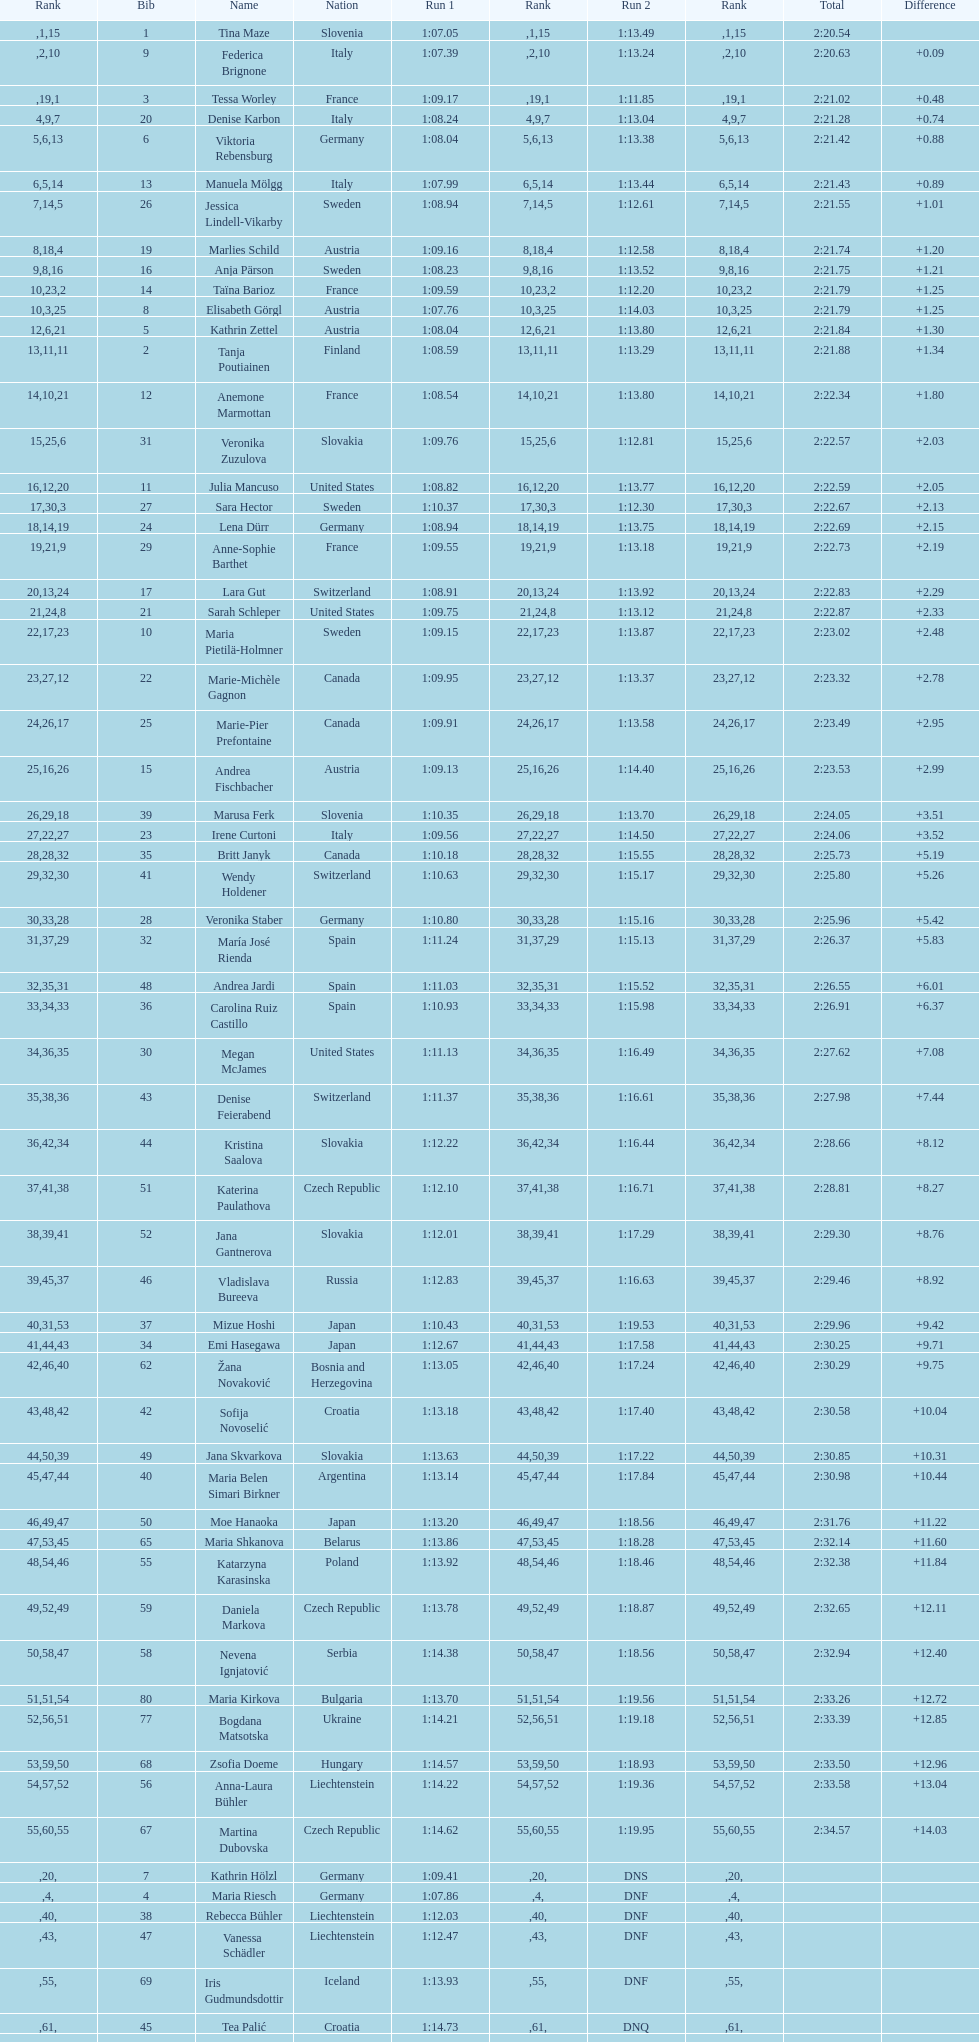Parse the full table. {'header': ['Rank', 'Bib', 'Name', 'Nation', 'Run 1', 'Rank', 'Run 2', 'Rank', 'Total', 'Difference'], 'rows': [['', '1', 'Tina Maze', 'Slovenia', '1:07.05', '1', '1:13.49', '15', '2:20.54', ''], ['', '9', 'Federica Brignone', 'Italy', '1:07.39', '2', '1:13.24', '10', '2:20.63', '+0.09'], ['', '3', 'Tessa Worley', 'France', '1:09.17', '19', '1:11.85', '1', '2:21.02', '+0.48'], ['4', '20', 'Denise Karbon', 'Italy', '1:08.24', '9', '1:13.04', '7', '2:21.28', '+0.74'], ['5', '6', 'Viktoria Rebensburg', 'Germany', '1:08.04', '6', '1:13.38', '13', '2:21.42', '+0.88'], ['6', '13', 'Manuela Mölgg', 'Italy', '1:07.99', '5', '1:13.44', '14', '2:21.43', '+0.89'], ['7', '26', 'Jessica Lindell-Vikarby', 'Sweden', '1:08.94', '14', '1:12.61', '5', '2:21.55', '+1.01'], ['8', '19', 'Marlies Schild', 'Austria', '1:09.16', '18', '1:12.58', '4', '2:21.74', '+1.20'], ['9', '16', 'Anja Pärson', 'Sweden', '1:08.23', '8', '1:13.52', '16', '2:21.75', '+1.21'], ['10', '14', 'Taïna Barioz', 'France', '1:09.59', '23', '1:12.20', '2', '2:21.79', '+1.25'], ['10', '8', 'Elisabeth Görgl', 'Austria', '1:07.76', '3', '1:14.03', '25', '2:21.79', '+1.25'], ['12', '5', 'Kathrin Zettel', 'Austria', '1:08.04', '6', '1:13.80', '21', '2:21.84', '+1.30'], ['13', '2', 'Tanja Poutiainen', 'Finland', '1:08.59', '11', '1:13.29', '11', '2:21.88', '+1.34'], ['14', '12', 'Anemone Marmottan', 'France', '1:08.54', '10', '1:13.80', '21', '2:22.34', '+1.80'], ['15', '31', 'Veronika Zuzulova', 'Slovakia', '1:09.76', '25', '1:12.81', '6', '2:22.57', '+2.03'], ['16', '11', 'Julia Mancuso', 'United States', '1:08.82', '12', '1:13.77', '20', '2:22.59', '+2.05'], ['17', '27', 'Sara Hector', 'Sweden', '1:10.37', '30', '1:12.30', '3', '2:22.67', '+2.13'], ['18', '24', 'Lena Dürr', 'Germany', '1:08.94', '14', '1:13.75', '19', '2:22.69', '+2.15'], ['19', '29', 'Anne-Sophie Barthet', 'France', '1:09.55', '21', '1:13.18', '9', '2:22.73', '+2.19'], ['20', '17', 'Lara Gut', 'Switzerland', '1:08.91', '13', '1:13.92', '24', '2:22.83', '+2.29'], ['21', '21', 'Sarah Schleper', 'United States', '1:09.75', '24', '1:13.12', '8', '2:22.87', '+2.33'], ['22', '10', 'Maria Pietilä-Holmner', 'Sweden', '1:09.15', '17', '1:13.87', '23', '2:23.02', '+2.48'], ['23', '22', 'Marie-Michèle Gagnon', 'Canada', '1:09.95', '27', '1:13.37', '12', '2:23.32', '+2.78'], ['24', '25', 'Marie-Pier Prefontaine', 'Canada', '1:09.91', '26', '1:13.58', '17', '2:23.49', '+2.95'], ['25', '15', 'Andrea Fischbacher', 'Austria', '1:09.13', '16', '1:14.40', '26', '2:23.53', '+2.99'], ['26', '39', 'Marusa Ferk', 'Slovenia', '1:10.35', '29', '1:13.70', '18', '2:24.05', '+3.51'], ['27', '23', 'Irene Curtoni', 'Italy', '1:09.56', '22', '1:14.50', '27', '2:24.06', '+3.52'], ['28', '35', 'Britt Janyk', 'Canada', '1:10.18', '28', '1:15.55', '32', '2:25.73', '+5.19'], ['29', '41', 'Wendy Holdener', 'Switzerland', '1:10.63', '32', '1:15.17', '30', '2:25.80', '+5.26'], ['30', '28', 'Veronika Staber', 'Germany', '1:10.80', '33', '1:15.16', '28', '2:25.96', '+5.42'], ['31', '32', 'María José Rienda', 'Spain', '1:11.24', '37', '1:15.13', '29', '2:26.37', '+5.83'], ['32', '48', 'Andrea Jardi', 'Spain', '1:11.03', '35', '1:15.52', '31', '2:26.55', '+6.01'], ['33', '36', 'Carolina Ruiz Castillo', 'Spain', '1:10.93', '34', '1:15.98', '33', '2:26.91', '+6.37'], ['34', '30', 'Megan McJames', 'United States', '1:11.13', '36', '1:16.49', '35', '2:27.62', '+7.08'], ['35', '43', 'Denise Feierabend', 'Switzerland', '1:11.37', '38', '1:16.61', '36', '2:27.98', '+7.44'], ['36', '44', 'Kristina Saalova', 'Slovakia', '1:12.22', '42', '1:16.44', '34', '2:28.66', '+8.12'], ['37', '51', 'Katerina Paulathova', 'Czech Republic', '1:12.10', '41', '1:16.71', '38', '2:28.81', '+8.27'], ['38', '52', 'Jana Gantnerova', 'Slovakia', '1:12.01', '39', '1:17.29', '41', '2:29.30', '+8.76'], ['39', '46', 'Vladislava Bureeva', 'Russia', '1:12.83', '45', '1:16.63', '37', '2:29.46', '+8.92'], ['40', '37', 'Mizue Hoshi', 'Japan', '1:10.43', '31', '1:19.53', '53', '2:29.96', '+9.42'], ['41', '34', 'Emi Hasegawa', 'Japan', '1:12.67', '44', '1:17.58', '43', '2:30.25', '+9.71'], ['42', '62', 'Žana Novaković', 'Bosnia and Herzegovina', '1:13.05', '46', '1:17.24', '40', '2:30.29', '+9.75'], ['43', '42', 'Sofija Novoselić', 'Croatia', '1:13.18', '48', '1:17.40', '42', '2:30.58', '+10.04'], ['44', '49', 'Jana Skvarkova', 'Slovakia', '1:13.63', '50', '1:17.22', '39', '2:30.85', '+10.31'], ['45', '40', 'Maria Belen Simari Birkner', 'Argentina', '1:13.14', '47', '1:17.84', '44', '2:30.98', '+10.44'], ['46', '50', 'Moe Hanaoka', 'Japan', '1:13.20', '49', '1:18.56', '47', '2:31.76', '+11.22'], ['47', '65', 'Maria Shkanova', 'Belarus', '1:13.86', '53', '1:18.28', '45', '2:32.14', '+11.60'], ['48', '55', 'Katarzyna Karasinska', 'Poland', '1:13.92', '54', '1:18.46', '46', '2:32.38', '+11.84'], ['49', '59', 'Daniela Markova', 'Czech Republic', '1:13.78', '52', '1:18.87', '49', '2:32.65', '+12.11'], ['50', '58', 'Nevena Ignjatović', 'Serbia', '1:14.38', '58', '1:18.56', '47', '2:32.94', '+12.40'], ['51', '80', 'Maria Kirkova', 'Bulgaria', '1:13.70', '51', '1:19.56', '54', '2:33.26', '+12.72'], ['52', '77', 'Bogdana Matsotska', 'Ukraine', '1:14.21', '56', '1:19.18', '51', '2:33.39', '+12.85'], ['53', '68', 'Zsofia Doeme', 'Hungary', '1:14.57', '59', '1:18.93', '50', '2:33.50', '+12.96'], ['54', '56', 'Anna-Laura Bühler', 'Liechtenstein', '1:14.22', '57', '1:19.36', '52', '2:33.58', '+13.04'], ['55', '67', 'Martina Dubovska', 'Czech Republic', '1:14.62', '60', '1:19.95', '55', '2:34.57', '+14.03'], ['', '7', 'Kathrin Hölzl', 'Germany', '1:09.41', '20', 'DNS', '', '', ''], ['', '4', 'Maria Riesch', 'Germany', '1:07.86', '4', 'DNF', '', '', ''], ['', '38', 'Rebecca Bühler', 'Liechtenstein', '1:12.03', '40', 'DNF', '', '', ''], ['', '47', 'Vanessa Schädler', 'Liechtenstein', '1:12.47', '43', 'DNF', '', '', ''], ['', '69', 'Iris Gudmundsdottir', 'Iceland', '1:13.93', '55', 'DNF', '', '', ''], ['', '45', 'Tea Palić', 'Croatia', '1:14.73', '61', 'DNQ', '', '', ''], ['', '74', 'Macarena Simari Birkner', 'Argentina', '1:15.18', '62', 'DNQ', '', '', ''], ['', '72', 'Lavinia Chrystal', 'Australia', '1:15.35', '63', 'DNQ', '', '', ''], ['', '81', 'Lelde Gasuna', 'Latvia', '1:15.37', '64', 'DNQ', '', '', ''], ['', '64', 'Aleksandra Klus', 'Poland', '1:15.41', '65', 'DNQ', '', '', ''], ['', '78', 'Nino Tsiklauri', 'Georgia', '1:15.54', '66', 'DNQ', '', '', ''], ['', '66', 'Sarah Jarvis', 'New Zealand', '1:15.94', '67', 'DNQ', '', '', ''], ['', '61', 'Anna Berecz', 'Hungary', '1:15.95', '68', 'DNQ', '', '', ''], ['', '83', 'Sandra-Elena Narea', 'Romania', '1:16.67', '69', 'DNQ', '', '', ''], ['', '85', 'Iulia Petruta Craciun', 'Romania', '1:16.80', '70', 'DNQ', '', '', ''], ['', '82', 'Isabel van Buynder', 'Belgium', '1:17.06', '71', 'DNQ', '', '', ''], ['', '97', 'Liene Fimbauere', 'Latvia', '1:17.83', '72', 'DNQ', '', '', ''], ['', '86', 'Kristina Krone', 'Puerto Rico', '1:17.93', '73', 'DNQ', '', '', ''], ['', '88', 'Nicole Valcareggi', 'Greece', '1:18.19', '74', 'DNQ', '', '', ''], ['', '100', 'Sophie Fjellvang-Sølling', 'Denmark', '1:18.37', '75', 'DNQ', '', '', ''], ['', '95', 'Ornella Oettl Reyes', 'Peru', '1:18.61', '76', 'DNQ', '', '', ''], ['', '73', 'Xia Lina', 'China', '1:19.12', '77', 'DNQ', '', '', ''], ['', '94', 'Kseniya Grigoreva', 'Uzbekistan', '1:19.16', '78', 'DNQ', '', '', ''], ['', '87', 'Tugba Dasdemir', 'Turkey', '1:21.50', '79', 'DNQ', '', '', ''], ['', '92', 'Malene Madsen', 'Denmark', '1:22.25', '80', 'DNQ', '', '', ''], ['', '84', 'Liu Yang', 'China', '1:22.80', '81', 'DNQ', '', '', ''], ['', '91', 'Yom Hirshfeld', 'Israel', '1:22.87', '82', 'DNQ', '', '', ''], ['', '75', 'Salome Bancora', 'Argentina', '1:23.08', '83', 'DNQ', '', '', ''], ['', '93', 'Ronnie Kiek-Gedalyahu', 'Israel', '1:23.38', '84', 'DNQ', '', '', ''], ['', '96', 'Chiara Marano', 'Brazil', '1:24.16', '85', 'DNQ', '', '', ''], ['', '113', 'Anne Libak Nielsen', 'Denmark', '1:25.08', '86', 'DNQ', '', '', ''], ['', '105', 'Donata Hellner', 'Hungary', '1:26.97', '87', 'DNQ', '', '', ''], ['', '102', 'Liu Yu', 'China', '1:27.03', '88', 'DNQ', '', '', ''], ['', '109', 'Lida Zvoznikova', 'Kyrgyzstan', '1:27.17', '89', 'DNQ', '', '', ''], ['', '103', 'Szelina Hellner', 'Hungary', '1:27.27', '90', 'DNQ', '', '', ''], ['', '114', 'Irina Volkova', 'Kyrgyzstan', '1:29.73', '91', 'DNQ', '', '', ''], ['', '106', 'Svetlana Baranova', 'Uzbekistan', '1:30.62', '92', 'DNQ', '', '', ''], ['', '108', 'Tatjana Baranova', 'Uzbekistan', '1:31.81', '93', 'DNQ', '', '', ''], ['', '110', 'Fatemeh Kiadarbandsari', 'Iran', '1:32.16', '94', 'DNQ', '', '', ''], ['', '107', 'Ziba Kalhor', 'Iran', '1:32.64', '95', 'DNQ', '', '', ''], ['', '104', 'Paraskevi Mavridou', 'Greece', '1:32.83', '96', 'DNQ', '', '', ''], ['', '99', 'Marjan Kalhor', 'Iran', '1:34.94', '97', 'DNQ', '', '', ''], ['', '112', 'Mitra Kalhor', 'Iran', '1:37.93', '98', 'DNQ', '', '', ''], ['', '115', 'Laura Bauer', 'South Africa', '1:42.19', '99', 'DNQ', '', '', ''], ['', '111', 'Sarah Ekmekejian', 'Lebanon', '1:42.22', '100', 'DNQ', '', '', ''], ['', '18', 'Fabienne Suter', 'Switzerland', 'DNS', '', '', '', '', ''], ['', '98', 'Maja Klepić', 'Bosnia and Herzegovina', 'DNS', '', '', '', '', ''], ['', '33', 'Agniezska Gasienica Daniel', 'Poland', 'DNF', '', '', '', '', ''], ['', '53', 'Karolina Chrapek', 'Poland', 'DNF', '', '', '', '', ''], ['', '54', 'Mireia Gutierrez', 'Andorra', 'DNF', '', '', '', '', ''], ['', '57', 'Brittany Phelan', 'Canada', 'DNF', '', '', '', '', ''], ['', '60', 'Tereza Kmochova', 'Czech Republic', 'DNF', '', '', '', '', ''], ['', '63', 'Michelle van Herwerden', 'Netherlands', 'DNF', '', '', '', '', ''], ['', '70', 'Maya Harrisson', 'Brazil', 'DNF', '', '', '', '', ''], ['', '71', 'Elizabeth Pilat', 'Australia', 'DNF', '', '', '', '', ''], ['', '76', 'Katrin Kristjansdottir', 'Iceland', 'DNF', '', '', '', '', ''], ['', '79', 'Julietta Quiroga', 'Argentina', 'DNF', '', '', '', '', ''], ['', '89', 'Evija Benhena', 'Latvia', 'DNF', '', '', '', '', ''], ['', '90', 'Qin Xiyue', 'China', 'DNF', '', '', '', '', ''], ['', '101', 'Sophia Ralli', 'Greece', 'DNF', '', '', '', '', ''], ['', '116', 'Siranush Maghakyan', 'Armenia', 'DNF', '', '', '', '', '']]} What is the last nation to be ranked? Czech Republic. 